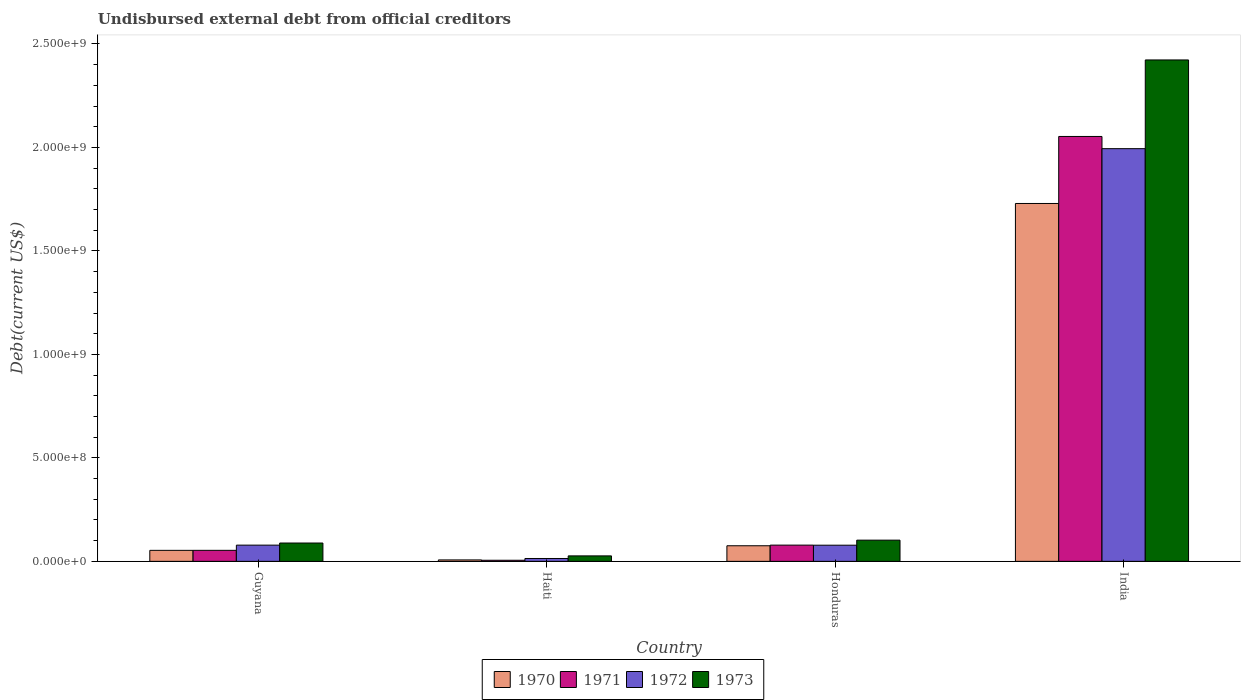Are the number of bars on each tick of the X-axis equal?
Offer a terse response. Yes. How many bars are there on the 1st tick from the right?
Ensure brevity in your answer.  4. What is the label of the 2nd group of bars from the left?
Make the answer very short. Haiti. What is the total debt in 1973 in Haiti?
Ensure brevity in your answer.  2.64e+07. Across all countries, what is the maximum total debt in 1972?
Give a very brief answer. 1.99e+09. Across all countries, what is the minimum total debt in 1972?
Provide a short and direct response. 1.39e+07. In which country was the total debt in 1971 minimum?
Ensure brevity in your answer.  Haiti. What is the total total debt in 1970 in the graph?
Ensure brevity in your answer.  1.86e+09. What is the difference between the total debt in 1971 in Guyana and that in India?
Give a very brief answer. -2.00e+09. What is the difference between the total debt in 1973 in Haiti and the total debt in 1971 in Honduras?
Offer a terse response. -5.20e+07. What is the average total debt in 1970 per country?
Your answer should be very brief. 4.66e+08. What is the difference between the total debt of/in 1972 and total debt of/in 1973 in Haiti?
Provide a succinct answer. -1.25e+07. In how many countries, is the total debt in 1970 greater than 1400000000 US$?
Your answer should be very brief. 1. What is the ratio of the total debt in 1971 in Haiti to that in India?
Your answer should be compact. 0. Is the total debt in 1971 in Guyana less than that in Honduras?
Ensure brevity in your answer.  Yes. What is the difference between the highest and the second highest total debt in 1972?
Provide a succinct answer. -1.92e+09. What is the difference between the highest and the lowest total debt in 1971?
Offer a very short reply. 2.05e+09. How many bars are there?
Provide a short and direct response. 16. Are all the bars in the graph horizontal?
Your response must be concise. No. What is the difference between two consecutive major ticks on the Y-axis?
Make the answer very short. 5.00e+08. Are the values on the major ticks of Y-axis written in scientific E-notation?
Ensure brevity in your answer.  Yes. Does the graph contain any zero values?
Your response must be concise. No. How many legend labels are there?
Offer a very short reply. 4. How are the legend labels stacked?
Offer a terse response. Horizontal. What is the title of the graph?
Provide a succinct answer. Undisbursed external debt from official creditors. Does "1975" appear as one of the legend labels in the graph?
Provide a succinct answer. No. What is the label or title of the Y-axis?
Your answer should be compact. Debt(current US$). What is the Debt(current US$) in 1970 in Guyana?
Keep it short and to the point. 5.32e+07. What is the Debt(current US$) of 1971 in Guyana?
Provide a succinct answer. 5.33e+07. What is the Debt(current US$) of 1972 in Guyana?
Make the answer very short. 7.84e+07. What is the Debt(current US$) of 1973 in Guyana?
Give a very brief answer. 8.86e+07. What is the Debt(current US$) in 1970 in Haiti?
Keep it short and to the point. 6.96e+06. What is the Debt(current US$) in 1971 in Haiti?
Offer a very short reply. 5.35e+06. What is the Debt(current US$) in 1972 in Haiti?
Your answer should be compact. 1.39e+07. What is the Debt(current US$) of 1973 in Haiti?
Your answer should be very brief. 2.64e+07. What is the Debt(current US$) of 1970 in Honduras?
Your response must be concise. 7.54e+07. What is the Debt(current US$) of 1971 in Honduras?
Offer a terse response. 7.85e+07. What is the Debt(current US$) of 1972 in Honduras?
Offer a terse response. 7.81e+07. What is the Debt(current US$) in 1973 in Honduras?
Make the answer very short. 1.02e+08. What is the Debt(current US$) in 1970 in India?
Your response must be concise. 1.73e+09. What is the Debt(current US$) in 1971 in India?
Ensure brevity in your answer.  2.05e+09. What is the Debt(current US$) in 1972 in India?
Keep it short and to the point. 1.99e+09. What is the Debt(current US$) of 1973 in India?
Keep it short and to the point. 2.42e+09. Across all countries, what is the maximum Debt(current US$) of 1970?
Provide a succinct answer. 1.73e+09. Across all countries, what is the maximum Debt(current US$) in 1971?
Give a very brief answer. 2.05e+09. Across all countries, what is the maximum Debt(current US$) in 1972?
Provide a succinct answer. 1.99e+09. Across all countries, what is the maximum Debt(current US$) in 1973?
Make the answer very short. 2.42e+09. Across all countries, what is the minimum Debt(current US$) of 1970?
Your answer should be very brief. 6.96e+06. Across all countries, what is the minimum Debt(current US$) in 1971?
Your response must be concise. 5.35e+06. Across all countries, what is the minimum Debt(current US$) in 1972?
Provide a short and direct response. 1.39e+07. Across all countries, what is the minimum Debt(current US$) of 1973?
Ensure brevity in your answer.  2.64e+07. What is the total Debt(current US$) in 1970 in the graph?
Your response must be concise. 1.86e+09. What is the total Debt(current US$) of 1971 in the graph?
Your response must be concise. 2.19e+09. What is the total Debt(current US$) of 1972 in the graph?
Make the answer very short. 2.16e+09. What is the total Debt(current US$) of 1973 in the graph?
Offer a very short reply. 2.64e+09. What is the difference between the Debt(current US$) in 1970 in Guyana and that in Haiti?
Your answer should be compact. 4.62e+07. What is the difference between the Debt(current US$) of 1971 in Guyana and that in Haiti?
Ensure brevity in your answer.  4.79e+07. What is the difference between the Debt(current US$) in 1972 in Guyana and that in Haiti?
Offer a very short reply. 6.45e+07. What is the difference between the Debt(current US$) in 1973 in Guyana and that in Haiti?
Your answer should be compact. 6.22e+07. What is the difference between the Debt(current US$) in 1970 in Guyana and that in Honduras?
Provide a short and direct response. -2.22e+07. What is the difference between the Debt(current US$) in 1971 in Guyana and that in Honduras?
Keep it short and to the point. -2.52e+07. What is the difference between the Debt(current US$) in 1972 in Guyana and that in Honduras?
Offer a very short reply. 2.49e+05. What is the difference between the Debt(current US$) in 1973 in Guyana and that in Honduras?
Keep it short and to the point. -1.39e+07. What is the difference between the Debt(current US$) in 1970 in Guyana and that in India?
Keep it short and to the point. -1.68e+09. What is the difference between the Debt(current US$) in 1971 in Guyana and that in India?
Your answer should be compact. -2.00e+09. What is the difference between the Debt(current US$) in 1972 in Guyana and that in India?
Ensure brevity in your answer.  -1.92e+09. What is the difference between the Debt(current US$) of 1973 in Guyana and that in India?
Keep it short and to the point. -2.33e+09. What is the difference between the Debt(current US$) in 1970 in Haiti and that in Honduras?
Provide a short and direct response. -6.84e+07. What is the difference between the Debt(current US$) of 1971 in Haiti and that in Honduras?
Offer a very short reply. -7.31e+07. What is the difference between the Debt(current US$) in 1972 in Haiti and that in Honduras?
Make the answer very short. -6.42e+07. What is the difference between the Debt(current US$) in 1973 in Haiti and that in Honduras?
Make the answer very short. -7.61e+07. What is the difference between the Debt(current US$) of 1970 in Haiti and that in India?
Provide a short and direct response. -1.72e+09. What is the difference between the Debt(current US$) of 1971 in Haiti and that in India?
Your response must be concise. -2.05e+09. What is the difference between the Debt(current US$) in 1972 in Haiti and that in India?
Ensure brevity in your answer.  -1.98e+09. What is the difference between the Debt(current US$) in 1973 in Haiti and that in India?
Provide a short and direct response. -2.40e+09. What is the difference between the Debt(current US$) of 1970 in Honduras and that in India?
Your answer should be very brief. -1.65e+09. What is the difference between the Debt(current US$) of 1971 in Honduras and that in India?
Your response must be concise. -1.97e+09. What is the difference between the Debt(current US$) in 1972 in Honduras and that in India?
Provide a succinct answer. -1.92e+09. What is the difference between the Debt(current US$) in 1973 in Honduras and that in India?
Ensure brevity in your answer.  -2.32e+09. What is the difference between the Debt(current US$) in 1970 in Guyana and the Debt(current US$) in 1971 in Haiti?
Provide a short and direct response. 4.78e+07. What is the difference between the Debt(current US$) of 1970 in Guyana and the Debt(current US$) of 1972 in Haiti?
Keep it short and to the point. 3.93e+07. What is the difference between the Debt(current US$) of 1970 in Guyana and the Debt(current US$) of 1973 in Haiti?
Keep it short and to the point. 2.68e+07. What is the difference between the Debt(current US$) in 1971 in Guyana and the Debt(current US$) in 1972 in Haiti?
Make the answer very short. 3.94e+07. What is the difference between the Debt(current US$) of 1971 in Guyana and the Debt(current US$) of 1973 in Haiti?
Your answer should be very brief. 2.68e+07. What is the difference between the Debt(current US$) in 1972 in Guyana and the Debt(current US$) in 1973 in Haiti?
Your response must be concise. 5.19e+07. What is the difference between the Debt(current US$) in 1970 in Guyana and the Debt(current US$) in 1971 in Honduras?
Offer a terse response. -2.53e+07. What is the difference between the Debt(current US$) of 1970 in Guyana and the Debt(current US$) of 1972 in Honduras?
Keep it short and to the point. -2.49e+07. What is the difference between the Debt(current US$) of 1970 in Guyana and the Debt(current US$) of 1973 in Honduras?
Provide a short and direct response. -4.93e+07. What is the difference between the Debt(current US$) in 1971 in Guyana and the Debt(current US$) in 1972 in Honduras?
Keep it short and to the point. -2.49e+07. What is the difference between the Debt(current US$) in 1971 in Guyana and the Debt(current US$) in 1973 in Honduras?
Your response must be concise. -4.92e+07. What is the difference between the Debt(current US$) in 1972 in Guyana and the Debt(current US$) in 1973 in Honduras?
Your answer should be compact. -2.41e+07. What is the difference between the Debt(current US$) of 1970 in Guyana and the Debt(current US$) of 1971 in India?
Give a very brief answer. -2.00e+09. What is the difference between the Debt(current US$) in 1970 in Guyana and the Debt(current US$) in 1972 in India?
Give a very brief answer. -1.94e+09. What is the difference between the Debt(current US$) in 1970 in Guyana and the Debt(current US$) in 1973 in India?
Keep it short and to the point. -2.37e+09. What is the difference between the Debt(current US$) in 1971 in Guyana and the Debt(current US$) in 1972 in India?
Ensure brevity in your answer.  -1.94e+09. What is the difference between the Debt(current US$) in 1971 in Guyana and the Debt(current US$) in 1973 in India?
Offer a terse response. -2.37e+09. What is the difference between the Debt(current US$) in 1972 in Guyana and the Debt(current US$) in 1973 in India?
Offer a very short reply. -2.34e+09. What is the difference between the Debt(current US$) in 1970 in Haiti and the Debt(current US$) in 1971 in Honduras?
Offer a very short reply. -7.15e+07. What is the difference between the Debt(current US$) of 1970 in Haiti and the Debt(current US$) of 1972 in Honduras?
Ensure brevity in your answer.  -7.12e+07. What is the difference between the Debt(current US$) of 1970 in Haiti and the Debt(current US$) of 1973 in Honduras?
Offer a terse response. -9.55e+07. What is the difference between the Debt(current US$) in 1971 in Haiti and the Debt(current US$) in 1972 in Honduras?
Offer a terse response. -7.28e+07. What is the difference between the Debt(current US$) of 1971 in Haiti and the Debt(current US$) of 1973 in Honduras?
Provide a short and direct response. -9.71e+07. What is the difference between the Debt(current US$) in 1972 in Haiti and the Debt(current US$) in 1973 in Honduras?
Offer a very short reply. -8.86e+07. What is the difference between the Debt(current US$) in 1970 in Haiti and the Debt(current US$) in 1971 in India?
Ensure brevity in your answer.  -2.05e+09. What is the difference between the Debt(current US$) in 1970 in Haiti and the Debt(current US$) in 1972 in India?
Keep it short and to the point. -1.99e+09. What is the difference between the Debt(current US$) of 1970 in Haiti and the Debt(current US$) of 1973 in India?
Provide a succinct answer. -2.42e+09. What is the difference between the Debt(current US$) of 1971 in Haiti and the Debt(current US$) of 1972 in India?
Offer a terse response. -1.99e+09. What is the difference between the Debt(current US$) in 1971 in Haiti and the Debt(current US$) in 1973 in India?
Provide a succinct answer. -2.42e+09. What is the difference between the Debt(current US$) in 1972 in Haiti and the Debt(current US$) in 1973 in India?
Keep it short and to the point. -2.41e+09. What is the difference between the Debt(current US$) in 1970 in Honduras and the Debt(current US$) in 1971 in India?
Your answer should be compact. -1.98e+09. What is the difference between the Debt(current US$) of 1970 in Honduras and the Debt(current US$) of 1972 in India?
Offer a very short reply. -1.92e+09. What is the difference between the Debt(current US$) in 1970 in Honduras and the Debt(current US$) in 1973 in India?
Your answer should be compact. -2.35e+09. What is the difference between the Debt(current US$) of 1971 in Honduras and the Debt(current US$) of 1972 in India?
Offer a terse response. -1.92e+09. What is the difference between the Debt(current US$) of 1971 in Honduras and the Debt(current US$) of 1973 in India?
Keep it short and to the point. -2.34e+09. What is the difference between the Debt(current US$) of 1972 in Honduras and the Debt(current US$) of 1973 in India?
Give a very brief answer. -2.34e+09. What is the average Debt(current US$) in 1970 per country?
Provide a short and direct response. 4.66e+08. What is the average Debt(current US$) in 1971 per country?
Offer a terse response. 5.48e+08. What is the average Debt(current US$) of 1972 per country?
Your answer should be compact. 5.41e+08. What is the average Debt(current US$) of 1973 per country?
Offer a very short reply. 6.60e+08. What is the difference between the Debt(current US$) of 1970 and Debt(current US$) of 1971 in Guyana?
Make the answer very short. -7.30e+04. What is the difference between the Debt(current US$) of 1970 and Debt(current US$) of 1972 in Guyana?
Your response must be concise. -2.52e+07. What is the difference between the Debt(current US$) of 1970 and Debt(current US$) of 1973 in Guyana?
Provide a succinct answer. -3.54e+07. What is the difference between the Debt(current US$) in 1971 and Debt(current US$) in 1972 in Guyana?
Give a very brief answer. -2.51e+07. What is the difference between the Debt(current US$) of 1971 and Debt(current US$) of 1973 in Guyana?
Make the answer very short. -3.53e+07. What is the difference between the Debt(current US$) of 1972 and Debt(current US$) of 1973 in Guyana?
Provide a short and direct response. -1.02e+07. What is the difference between the Debt(current US$) of 1970 and Debt(current US$) of 1971 in Haiti?
Make the answer very short. 1.61e+06. What is the difference between the Debt(current US$) in 1970 and Debt(current US$) in 1972 in Haiti?
Provide a short and direct response. -6.92e+06. What is the difference between the Debt(current US$) of 1970 and Debt(current US$) of 1973 in Haiti?
Offer a very short reply. -1.95e+07. What is the difference between the Debt(current US$) of 1971 and Debt(current US$) of 1972 in Haiti?
Provide a succinct answer. -8.53e+06. What is the difference between the Debt(current US$) of 1971 and Debt(current US$) of 1973 in Haiti?
Offer a terse response. -2.11e+07. What is the difference between the Debt(current US$) of 1972 and Debt(current US$) of 1973 in Haiti?
Give a very brief answer. -1.25e+07. What is the difference between the Debt(current US$) in 1970 and Debt(current US$) in 1971 in Honduras?
Keep it short and to the point. -3.06e+06. What is the difference between the Debt(current US$) in 1970 and Debt(current US$) in 1972 in Honduras?
Offer a terse response. -2.72e+06. What is the difference between the Debt(current US$) in 1970 and Debt(current US$) in 1973 in Honduras?
Give a very brief answer. -2.71e+07. What is the difference between the Debt(current US$) of 1971 and Debt(current US$) of 1972 in Honduras?
Provide a succinct answer. 3.37e+05. What is the difference between the Debt(current US$) of 1971 and Debt(current US$) of 1973 in Honduras?
Give a very brief answer. -2.40e+07. What is the difference between the Debt(current US$) in 1972 and Debt(current US$) in 1973 in Honduras?
Offer a very short reply. -2.44e+07. What is the difference between the Debt(current US$) of 1970 and Debt(current US$) of 1971 in India?
Provide a short and direct response. -3.24e+08. What is the difference between the Debt(current US$) of 1970 and Debt(current US$) of 1972 in India?
Make the answer very short. -2.65e+08. What is the difference between the Debt(current US$) of 1970 and Debt(current US$) of 1973 in India?
Ensure brevity in your answer.  -6.94e+08. What is the difference between the Debt(current US$) of 1971 and Debt(current US$) of 1972 in India?
Give a very brief answer. 5.89e+07. What is the difference between the Debt(current US$) in 1971 and Debt(current US$) in 1973 in India?
Give a very brief answer. -3.70e+08. What is the difference between the Debt(current US$) of 1972 and Debt(current US$) of 1973 in India?
Your answer should be very brief. -4.29e+08. What is the ratio of the Debt(current US$) of 1970 in Guyana to that in Haiti?
Your answer should be very brief. 7.64. What is the ratio of the Debt(current US$) in 1971 in Guyana to that in Haiti?
Your answer should be very brief. 9.95. What is the ratio of the Debt(current US$) in 1972 in Guyana to that in Haiti?
Make the answer very short. 5.64. What is the ratio of the Debt(current US$) of 1973 in Guyana to that in Haiti?
Provide a succinct answer. 3.35. What is the ratio of the Debt(current US$) in 1970 in Guyana to that in Honduras?
Provide a succinct answer. 0.71. What is the ratio of the Debt(current US$) in 1971 in Guyana to that in Honduras?
Provide a short and direct response. 0.68. What is the ratio of the Debt(current US$) of 1972 in Guyana to that in Honduras?
Keep it short and to the point. 1. What is the ratio of the Debt(current US$) in 1973 in Guyana to that in Honduras?
Keep it short and to the point. 0.86. What is the ratio of the Debt(current US$) in 1970 in Guyana to that in India?
Your answer should be compact. 0.03. What is the ratio of the Debt(current US$) in 1971 in Guyana to that in India?
Your response must be concise. 0.03. What is the ratio of the Debt(current US$) in 1972 in Guyana to that in India?
Your answer should be compact. 0.04. What is the ratio of the Debt(current US$) in 1973 in Guyana to that in India?
Give a very brief answer. 0.04. What is the ratio of the Debt(current US$) in 1970 in Haiti to that in Honduras?
Offer a terse response. 0.09. What is the ratio of the Debt(current US$) in 1971 in Haiti to that in Honduras?
Your answer should be compact. 0.07. What is the ratio of the Debt(current US$) of 1972 in Haiti to that in Honduras?
Ensure brevity in your answer.  0.18. What is the ratio of the Debt(current US$) of 1973 in Haiti to that in Honduras?
Offer a very short reply. 0.26. What is the ratio of the Debt(current US$) in 1970 in Haiti to that in India?
Your answer should be very brief. 0. What is the ratio of the Debt(current US$) in 1971 in Haiti to that in India?
Make the answer very short. 0. What is the ratio of the Debt(current US$) in 1972 in Haiti to that in India?
Ensure brevity in your answer.  0.01. What is the ratio of the Debt(current US$) of 1973 in Haiti to that in India?
Make the answer very short. 0.01. What is the ratio of the Debt(current US$) in 1970 in Honduras to that in India?
Provide a succinct answer. 0.04. What is the ratio of the Debt(current US$) of 1971 in Honduras to that in India?
Your answer should be very brief. 0.04. What is the ratio of the Debt(current US$) in 1972 in Honduras to that in India?
Provide a succinct answer. 0.04. What is the ratio of the Debt(current US$) in 1973 in Honduras to that in India?
Ensure brevity in your answer.  0.04. What is the difference between the highest and the second highest Debt(current US$) in 1970?
Make the answer very short. 1.65e+09. What is the difference between the highest and the second highest Debt(current US$) in 1971?
Your answer should be very brief. 1.97e+09. What is the difference between the highest and the second highest Debt(current US$) of 1972?
Give a very brief answer. 1.92e+09. What is the difference between the highest and the second highest Debt(current US$) in 1973?
Offer a very short reply. 2.32e+09. What is the difference between the highest and the lowest Debt(current US$) in 1970?
Your response must be concise. 1.72e+09. What is the difference between the highest and the lowest Debt(current US$) of 1971?
Your answer should be compact. 2.05e+09. What is the difference between the highest and the lowest Debt(current US$) of 1972?
Provide a short and direct response. 1.98e+09. What is the difference between the highest and the lowest Debt(current US$) of 1973?
Give a very brief answer. 2.40e+09. 